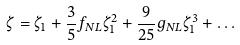<formula> <loc_0><loc_0><loc_500><loc_500>\zeta = \zeta _ { 1 } + \frac { 3 } { 5 } f _ { N L } \zeta _ { 1 } ^ { 2 } + \frac { 9 } { 2 5 } g _ { N L } \zeta _ { 1 } ^ { 3 } + \dots</formula> 